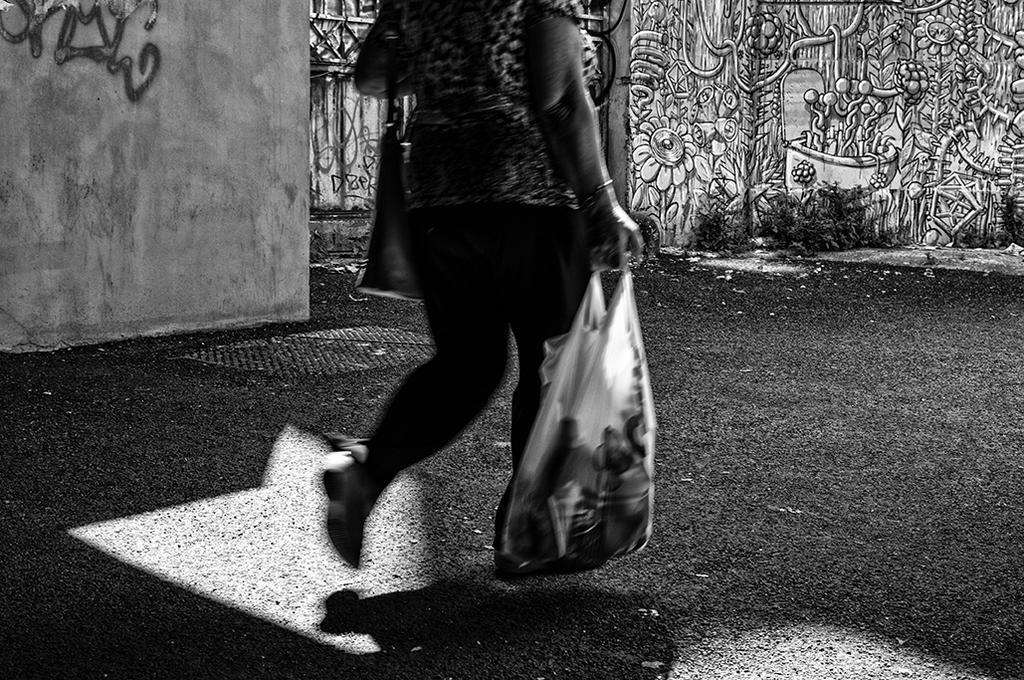Describe this image in one or two sentences. This picture is clicked outside. In the center we can see a person wearing a sling bag, holding a bag of some objects and walking on the ground. In the background we can see the plants and some art on the walls. 